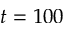<formula> <loc_0><loc_0><loc_500><loc_500>t = 1 0 0</formula> 